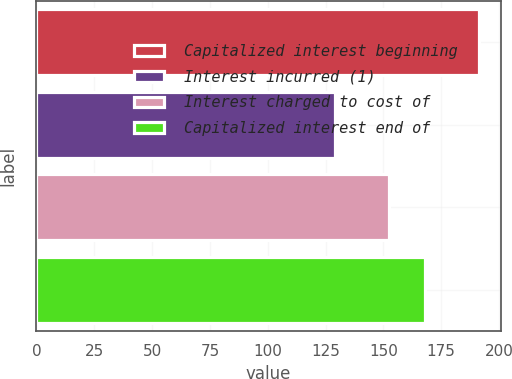<chart> <loc_0><loc_0><loc_500><loc_500><bar_chart><fcel>Capitalized interest beginning<fcel>Interest incurred (1)<fcel>Interest charged to cost of<fcel>Capitalized interest end of<nl><fcel>191.2<fcel>129.3<fcel>152.6<fcel>167.9<nl></chart> 